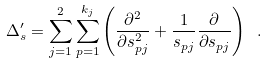<formula> <loc_0><loc_0><loc_500><loc_500>\Delta ^ { \prime } _ { s } = \sum _ { j = 1 } ^ { 2 } \sum _ { p = 1 } ^ { k _ { j } } \left ( \frac { \partial ^ { 2 } } { \partial s _ { p j } ^ { 2 } } + \frac { 1 } { s _ { p j } } \frac { \partial } { \partial s _ { p j } } \right ) \ .</formula> 